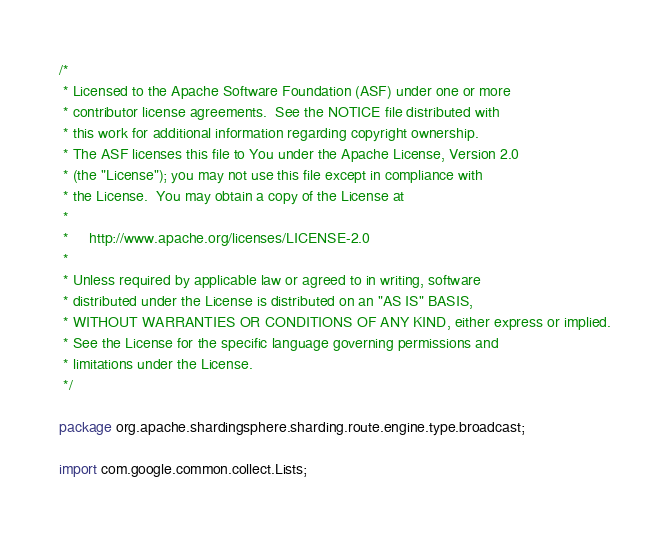<code> <loc_0><loc_0><loc_500><loc_500><_Java_>/*
 * Licensed to the Apache Software Foundation (ASF) under one or more
 * contributor license agreements.  See the NOTICE file distributed with
 * this work for additional information regarding copyright ownership.
 * The ASF licenses this file to You under the Apache License, Version 2.0
 * (the "License"); you may not use this file except in compliance with
 * the License.  You may obtain a copy of the License at
 *
 *     http://www.apache.org/licenses/LICENSE-2.0
 *
 * Unless required by applicable law or agreed to in writing, software
 * distributed under the License is distributed on an "AS IS" BASIS,
 * WITHOUT WARRANTIES OR CONDITIONS OF ANY KIND, either express or implied.
 * See the License for the specific language governing permissions and
 * limitations under the License.
 */

package org.apache.shardingsphere.sharding.route.engine.type.broadcast;

import com.google.common.collect.Lists;</code> 